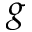<formula> <loc_0><loc_0><loc_500><loc_500>g</formula> 